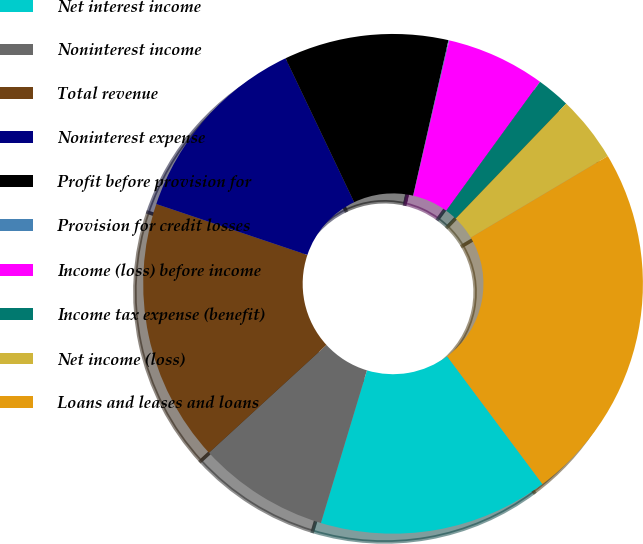Convert chart to OTSL. <chart><loc_0><loc_0><loc_500><loc_500><pie_chart><fcel>Net interest income<fcel>Noninterest income<fcel>Total revenue<fcel>Noninterest expense<fcel>Profit before provision for<fcel>Provision for credit losses<fcel>Income (loss) before income<fcel>Income tax expense (benefit)<fcel>Net income (loss)<fcel>Loans and leases and loans<nl><fcel>14.87%<fcel>8.52%<fcel>16.99%<fcel>12.75%<fcel>10.64%<fcel>0.05%<fcel>6.4%<fcel>2.17%<fcel>4.28%<fcel>23.34%<nl></chart> 